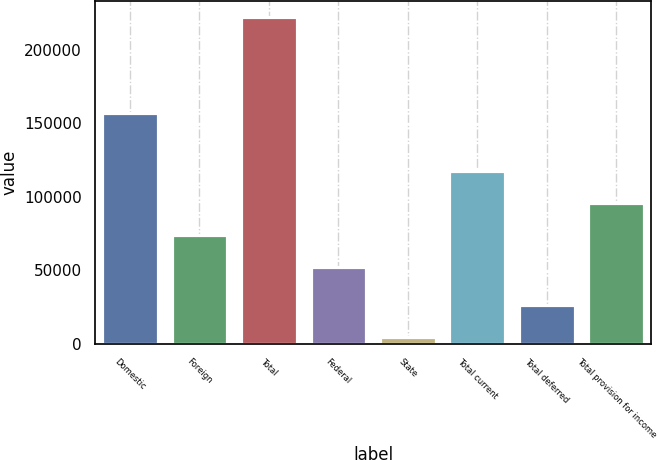Convert chart. <chart><loc_0><loc_0><loc_500><loc_500><bar_chart><fcel>Domestic<fcel>Foreign<fcel>Total<fcel>Federal<fcel>State<fcel>Total current<fcel>Total deferred<fcel>Total provision for income<nl><fcel>157027<fcel>74023.3<fcel>222126<fcel>52290<fcel>4793<fcel>117490<fcel>26526.3<fcel>95756.6<nl></chart> 